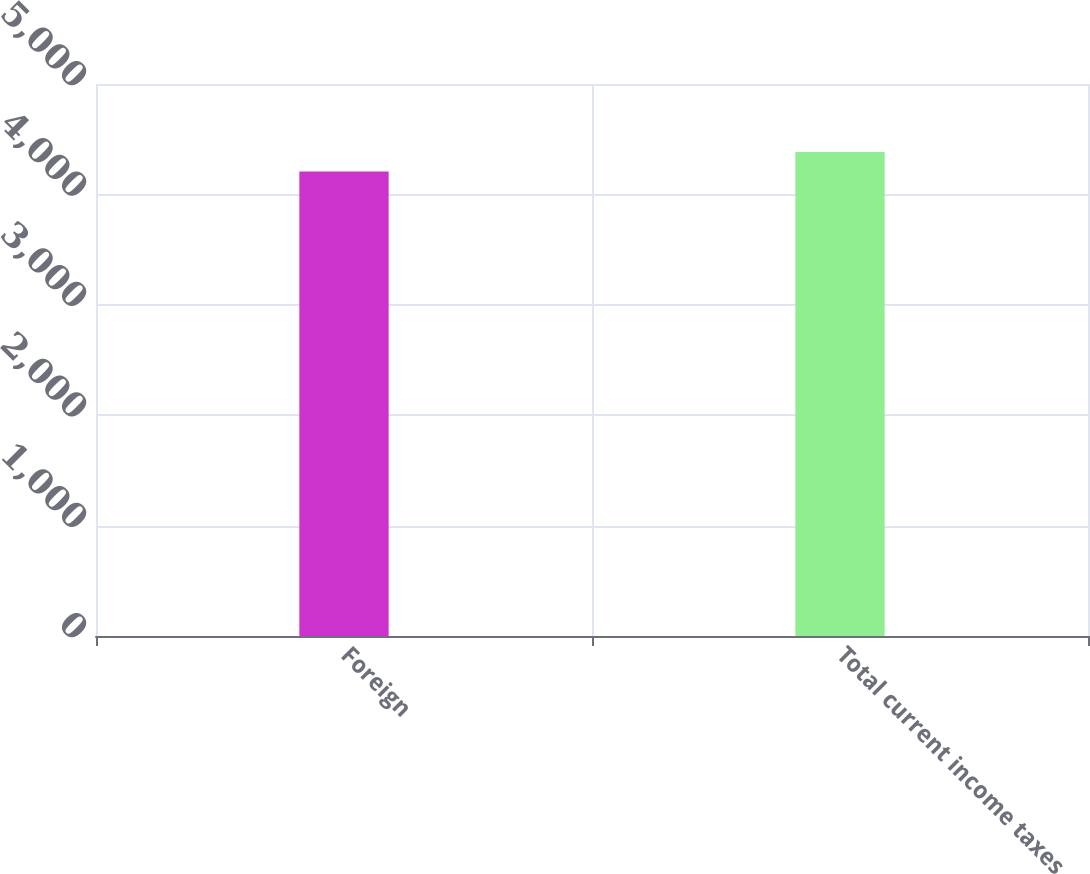<chart> <loc_0><loc_0><loc_500><loc_500><bar_chart><fcel>Foreign<fcel>Total current income taxes<nl><fcel>4208<fcel>4385<nl></chart> 